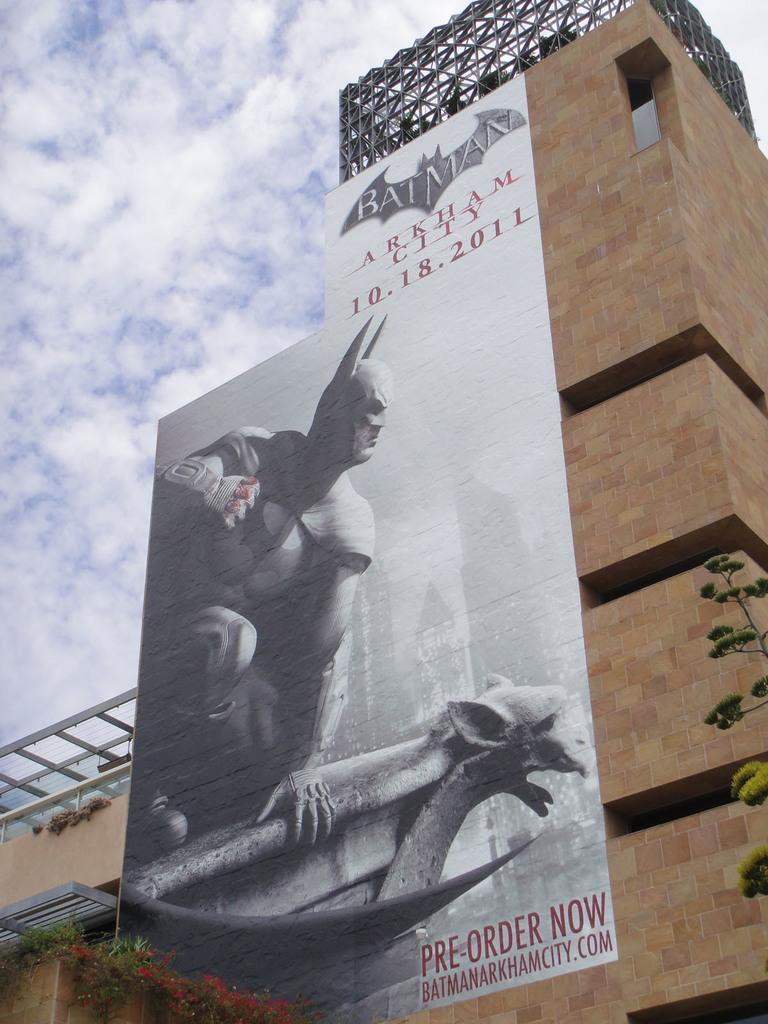What is the name of the book?
Your answer should be very brief. Batman arkham city. 